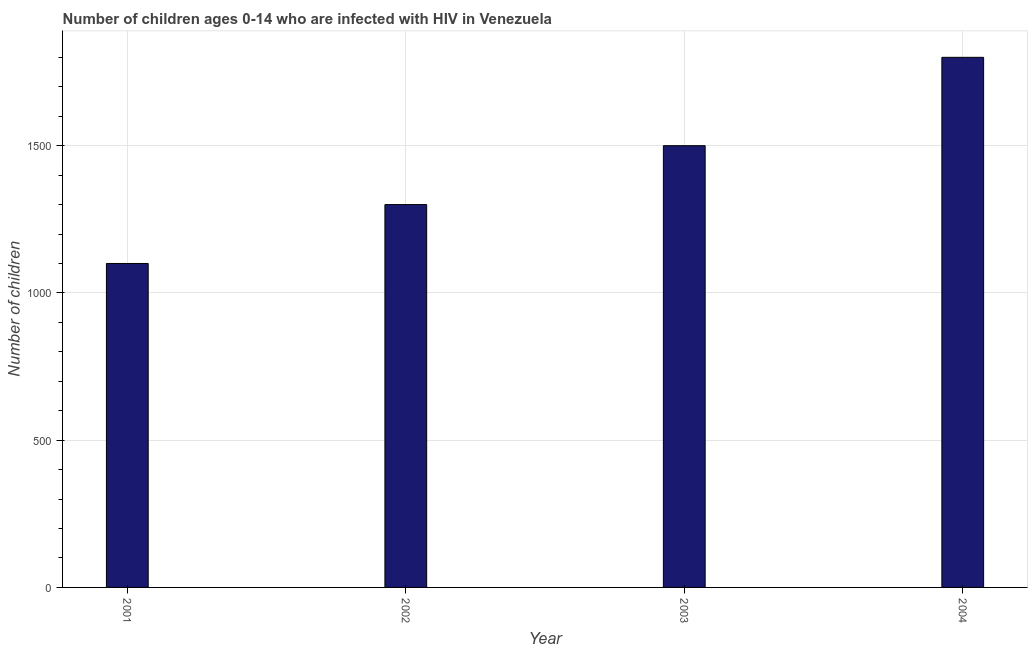What is the title of the graph?
Offer a very short reply. Number of children ages 0-14 who are infected with HIV in Venezuela. What is the label or title of the Y-axis?
Your response must be concise. Number of children. What is the number of children living with hiv in 2004?
Give a very brief answer. 1800. Across all years, what is the maximum number of children living with hiv?
Your response must be concise. 1800. Across all years, what is the minimum number of children living with hiv?
Provide a short and direct response. 1100. In which year was the number of children living with hiv minimum?
Your answer should be very brief. 2001. What is the sum of the number of children living with hiv?
Ensure brevity in your answer.  5700. What is the difference between the number of children living with hiv in 2002 and 2004?
Ensure brevity in your answer.  -500. What is the average number of children living with hiv per year?
Give a very brief answer. 1425. What is the median number of children living with hiv?
Provide a short and direct response. 1400. In how many years, is the number of children living with hiv greater than 1600 ?
Your answer should be very brief. 1. Do a majority of the years between 2003 and 2004 (inclusive) have number of children living with hiv greater than 1200 ?
Give a very brief answer. Yes. What is the ratio of the number of children living with hiv in 2002 to that in 2003?
Your answer should be compact. 0.87. Is the number of children living with hiv in 2001 less than that in 2003?
Your answer should be very brief. Yes. What is the difference between the highest and the second highest number of children living with hiv?
Your answer should be very brief. 300. What is the difference between the highest and the lowest number of children living with hiv?
Provide a short and direct response. 700. Are all the bars in the graph horizontal?
Provide a short and direct response. No. Are the values on the major ticks of Y-axis written in scientific E-notation?
Your response must be concise. No. What is the Number of children of 2001?
Your response must be concise. 1100. What is the Number of children in 2002?
Offer a terse response. 1300. What is the Number of children in 2003?
Provide a short and direct response. 1500. What is the Number of children in 2004?
Ensure brevity in your answer.  1800. What is the difference between the Number of children in 2001 and 2002?
Keep it short and to the point. -200. What is the difference between the Number of children in 2001 and 2003?
Offer a terse response. -400. What is the difference between the Number of children in 2001 and 2004?
Offer a terse response. -700. What is the difference between the Number of children in 2002 and 2003?
Give a very brief answer. -200. What is the difference between the Number of children in 2002 and 2004?
Offer a terse response. -500. What is the difference between the Number of children in 2003 and 2004?
Offer a very short reply. -300. What is the ratio of the Number of children in 2001 to that in 2002?
Offer a very short reply. 0.85. What is the ratio of the Number of children in 2001 to that in 2003?
Provide a succinct answer. 0.73. What is the ratio of the Number of children in 2001 to that in 2004?
Provide a short and direct response. 0.61. What is the ratio of the Number of children in 2002 to that in 2003?
Your response must be concise. 0.87. What is the ratio of the Number of children in 2002 to that in 2004?
Offer a terse response. 0.72. What is the ratio of the Number of children in 2003 to that in 2004?
Your answer should be very brief. 0.83. 